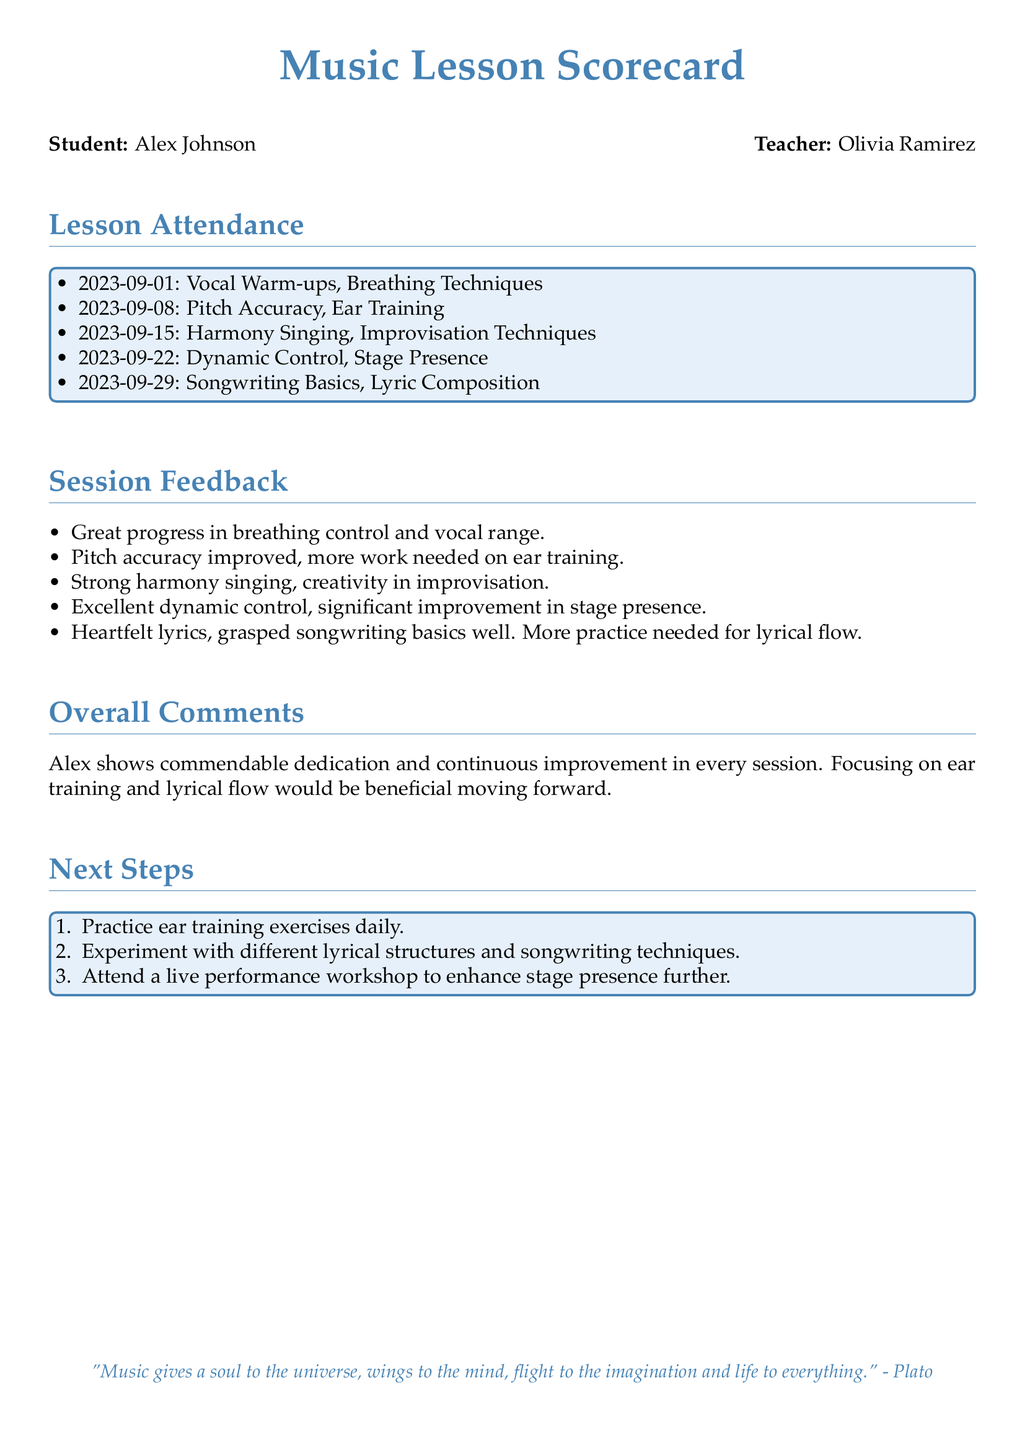What is the student's name? The student's name is listed at the top of the scorecard under the Student section.
Answer: Alex Johnson Who is the teacher? The teacher's name is provided next to the Teacher section in the document.
Answer: Olivia Ramirez How many sessions were attended in September 2023? The number of sessions can be counted from the Lesson Attendance section, which lists 5 dates in September 2023.
Answer: 5 What feedback did Alex receive about breathing control? The feedback remarks on specific progress made during the sessions, particularly about breathing control.
Answer: Great progress What was noted about Alex's pitch accuracy? The feedback mentions specific aspects of pitch accuracy that require attention or improvement.
Answer: More work needed What songwriting element needs more practice? The feedback on songwriting mentions the specific area that requires additional practice.
Answer: Lyrical flow What is one suggested next step for Alex? The Next Steps section outlines specific actions Alex can take moving forward.
Answer: Practice ear training exercises daily How did Alex improve in stage presence? The feedback highlights Alex's performance skills during sessions, particularly in relation to stage presence.
Answer: Significant improvement 